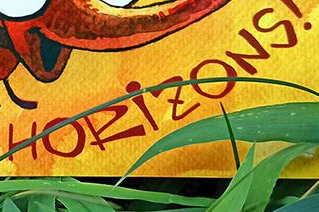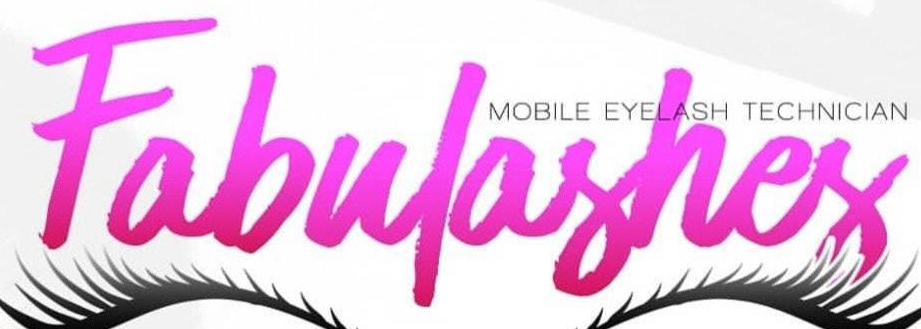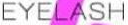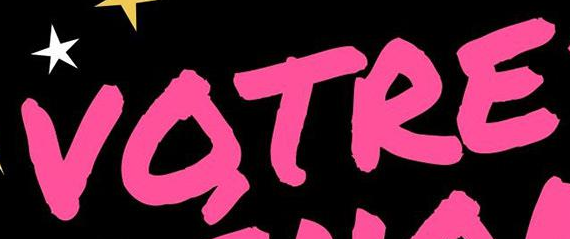Transcribe the words shown in these images in order, separated by a semicolon. HORiZONS; Fabulashes; EYELASH; VOTRE 